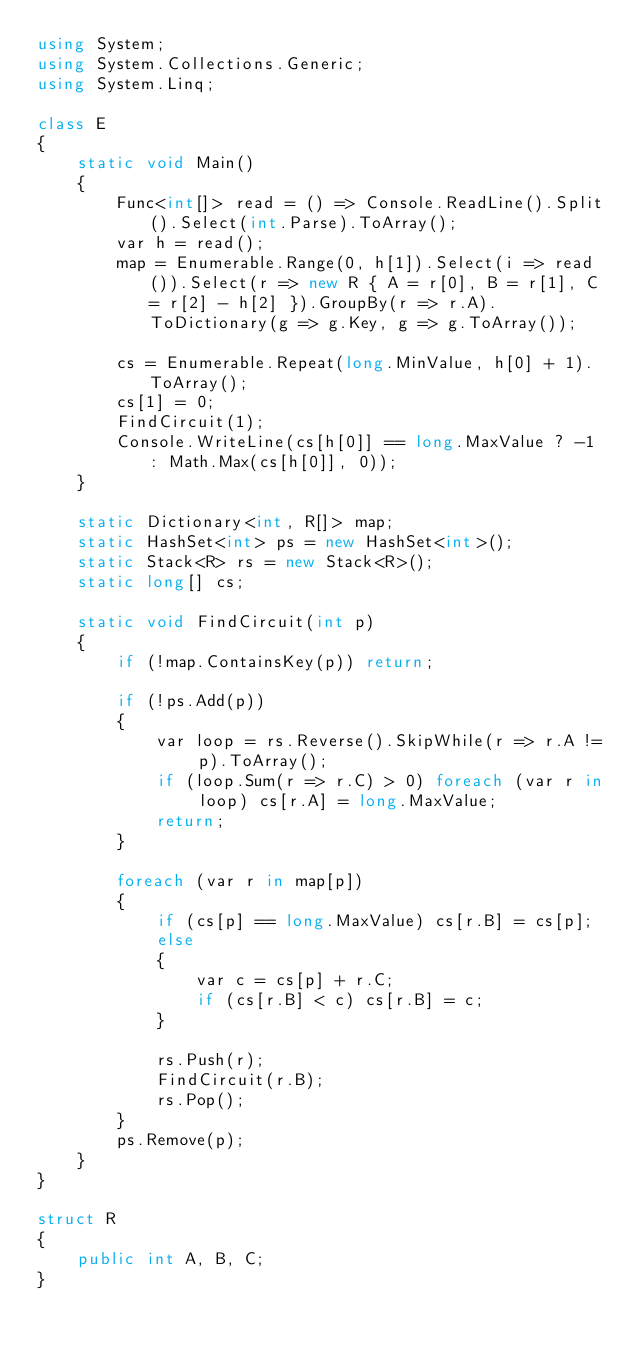<code> <loc_0><loc_0><loc_500><loc_500><_C#_>using System;
using System.Collections.Generic;
using System.Linq;

class E
{
	static void Main()
	{
		Func<int[]> read = () => Console.ReadLine().Split().Select(int.Parse).ToArray();
		var h = read();
		map = Enumerable.Range(0, h[1]).Select(i => read()).Select(r => new R { A = r[0], B = r[1], C = r[2] - h[2] }).GroupBy(r => r.A).ToDictionary(g => g.Key, g => g.ToArray());

		cs = Enumerable.Repeat(long.MinValue, h[0] + 1).ToArray();
		cs[1] = 0;
		FindCircuit(1);
		Console.WriteLine(cs[h[0]] == long.MaxValue ? -1 : Math.Max(cs[h[0]], 0));
	}

	static Dictionary<int, R[]> map;
	static HashSet<int> ps = new HashSet<int>();
	static Stack<R> rs = new Stack<R>();
	static long[] cs;

	static void FindCircuit(int p)
	{
		if (!map.ContainsKey(p)) return;

		if (!ps.Add(p))
		{
			var loop = rs.Reverse().SkipWhile(r => r.A != p).ToArray();
			if (loop.Sum(r => r.C) > 0) foreach (var r in loop) cs[r.A] = long.MaxValue;
			return;
		}

		foreach (var r in map[p])
		{
			if (cs[p] == long.MaxValue) cs[r.B] = cs[p];
			else
			{
				var c = cs[p] + r.C;
				if (cs[r.B] < c) cs[r.B] = c;
			}

			rs.Push(r);
			FindCircuit(r.B);
			rs.Pop();
		}
		ps.Remove(p);
	}
}

struct R
{
	public int A, B, C;
}
</code> 